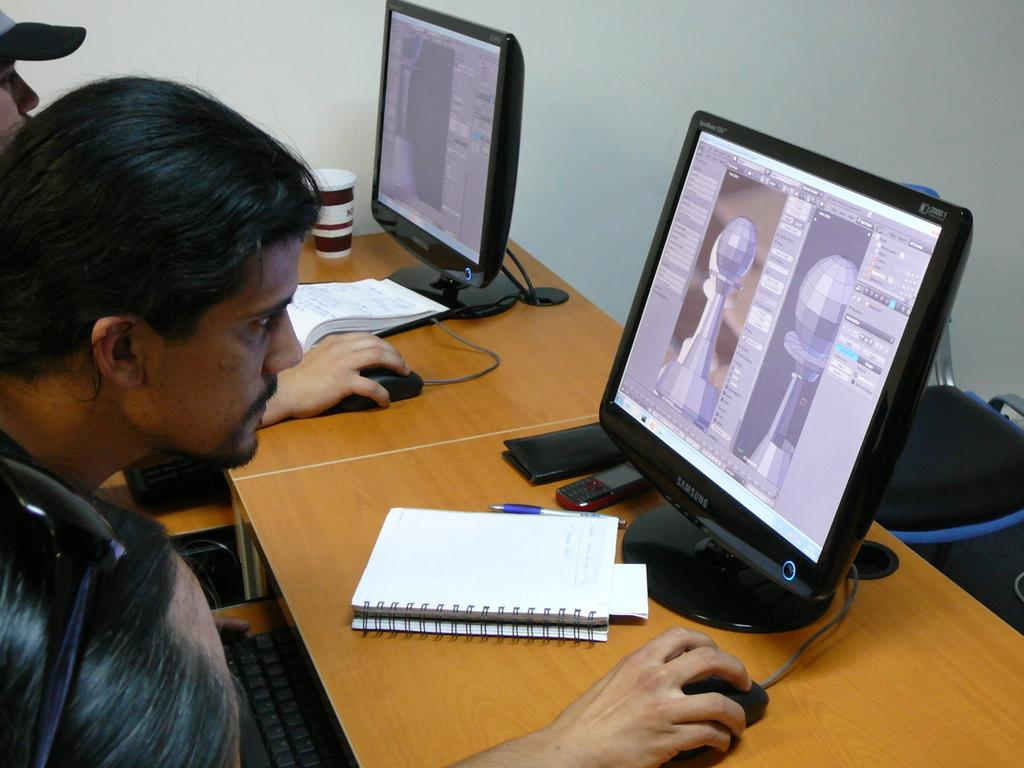How many computers are on the table in the image? There are two computers on the table. What other objects can be seen on the table? There are two books and two pens on the table. What are the persons in the image doing? The persons are sitting on chairs and working on the computers. What type of coat is the son wearing in the image? There is no son or coat present in the image. What kind of ray is visible in the image? There is no ray present in the image. 